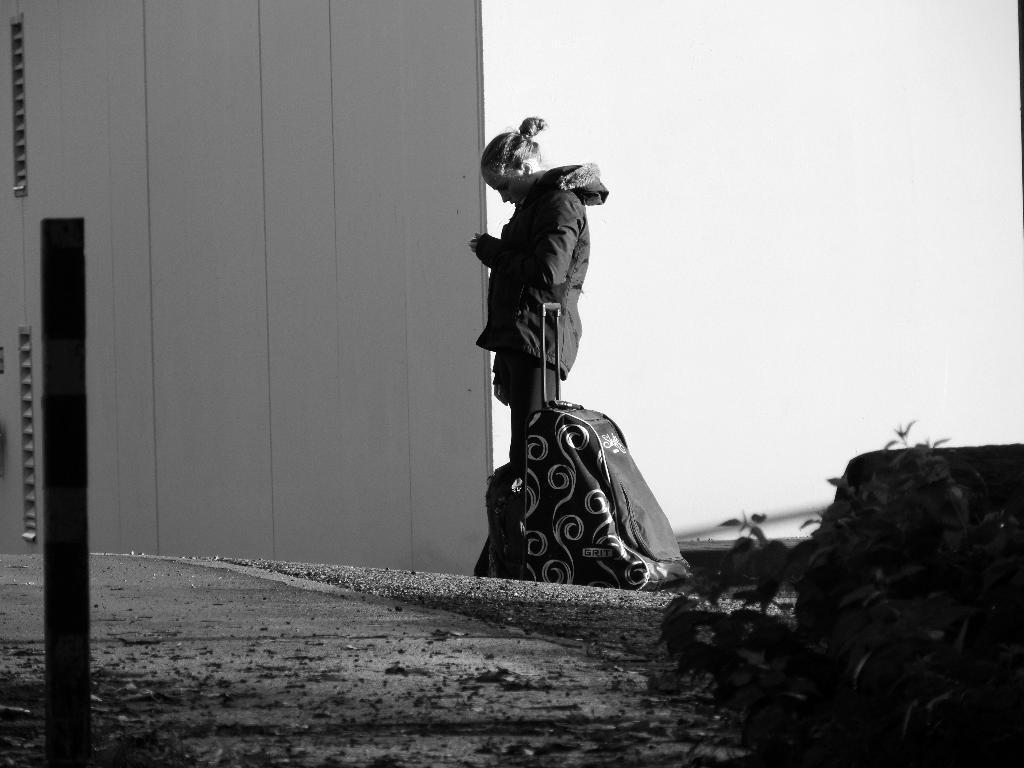Can you describe this image briefly? In this picture a person is standing on the road. Beside her there is a bag. In front of her there is a wall. 